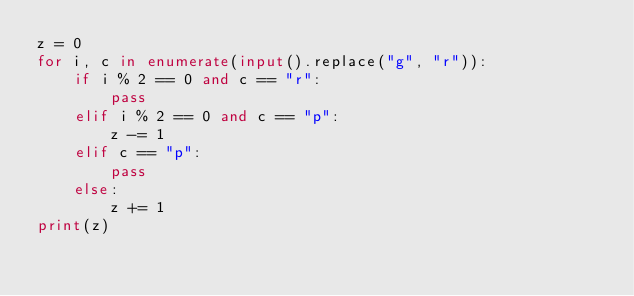<code> <loc_0><loc_0><loc_500><loc_500><_Python_>z = 0
for i, c in enumerate(input().replace("g", "r")):
    if i % 2 == 0 and c == "r":
        pass
    elif i % 2 == 0 and c == "p":
        z -= 1
    elif c == "p":
        pass
    else:
        z += 1
print(z)
</code> 